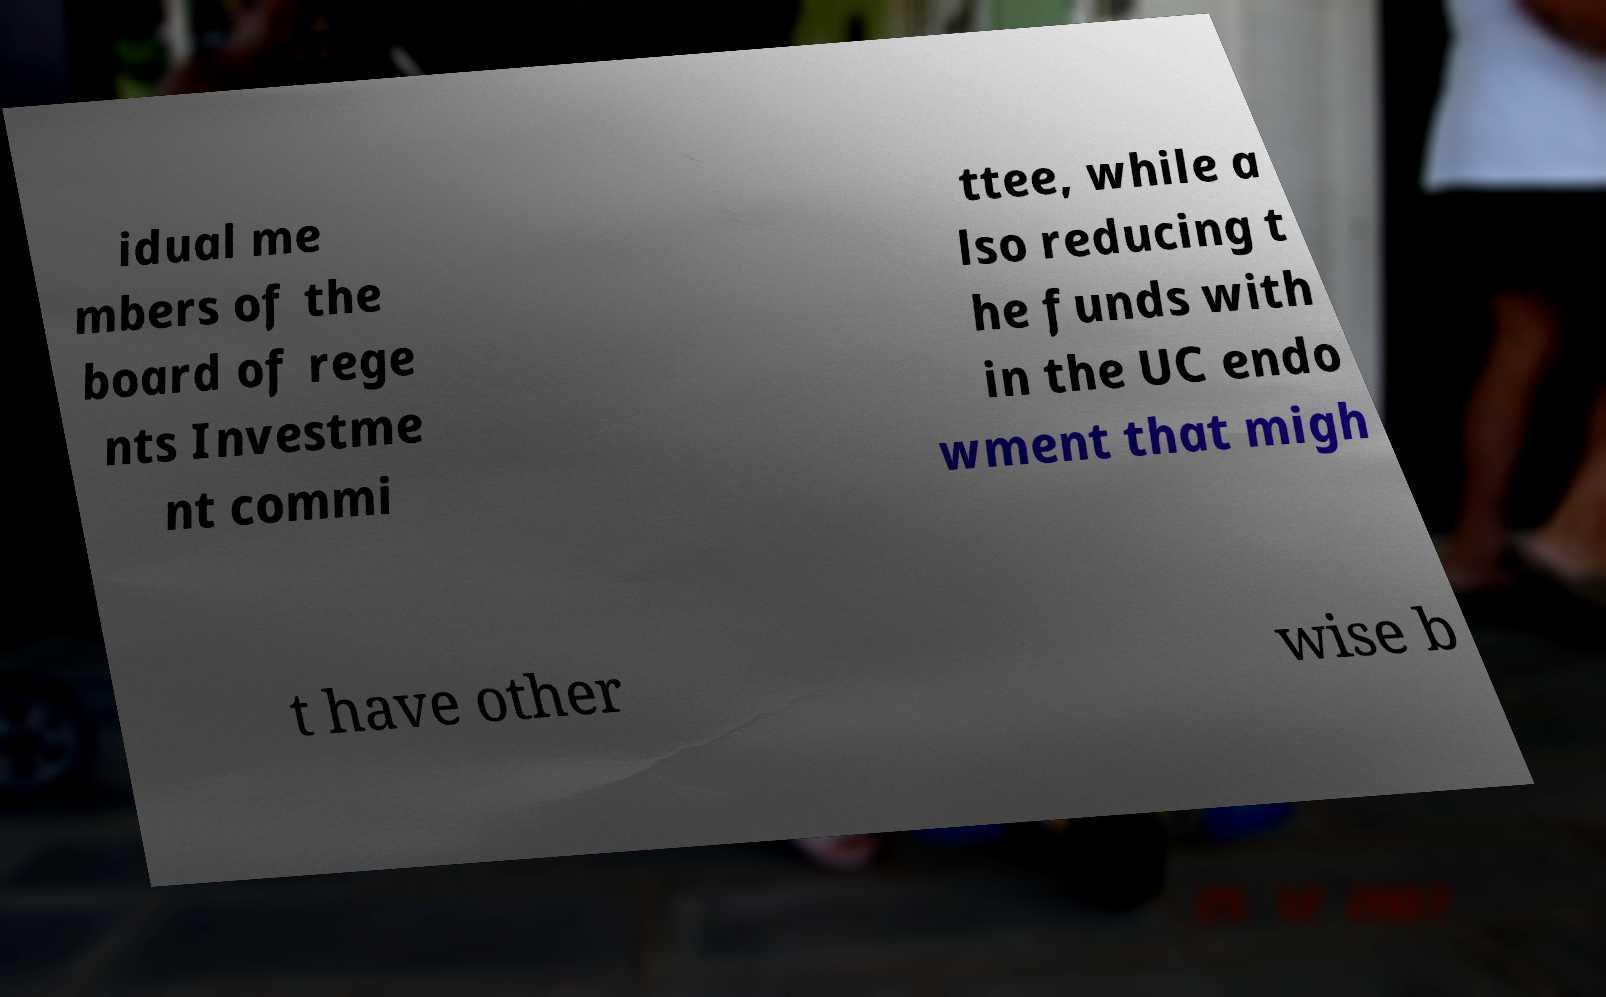Can you read and provide the text displayed in the image?This photo seems to have some interesting text. Can you extract and type it out for me? idual me mbers of the board of rege nts Investme nt commi ttee, while a lso reducing t he funds with in the UC endo wment that migh t have other wise b 